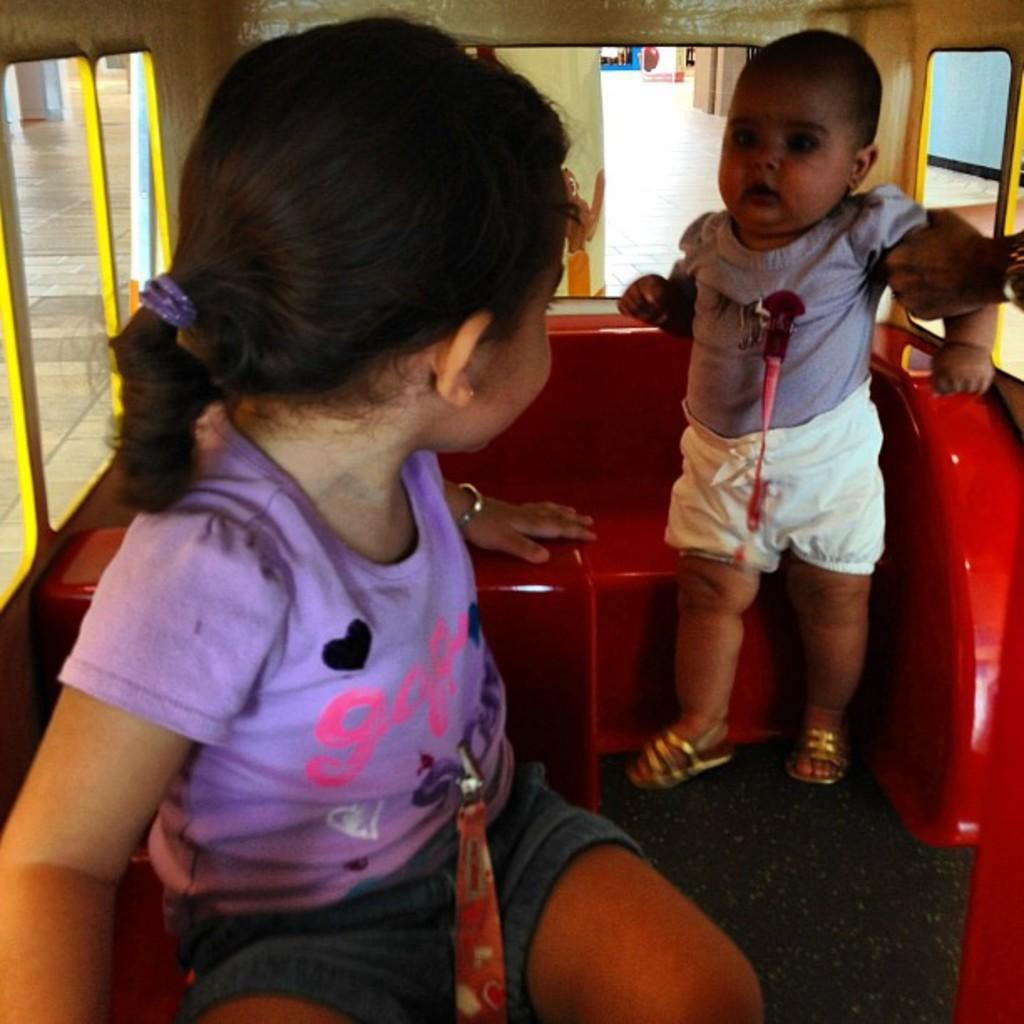Who is present in the image? There are children in the image. Where are the children located? The children are inside a vehicle. What is the position of the vehicle in the image? The vehicle is in the foreground of the image. What type of hen can be seen in the image? There is no hen present in the image. How does the whistle sound in the image? There is no whistle present in the image. 